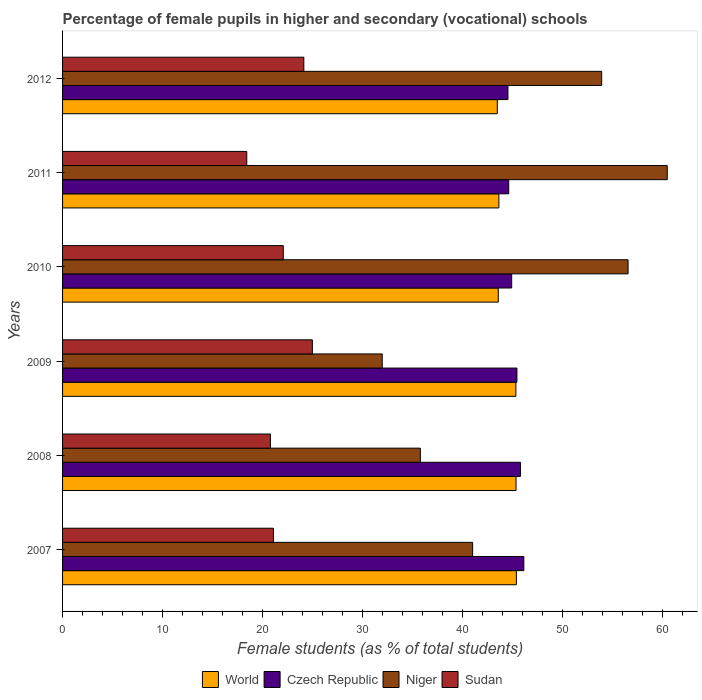How many different coloured bars are there?
Give a very brief answer. 4. How many groups of bars are there?
Provide a short and direct response. 6. How many bars are there on the 1st tick from the top?
Ensure brevity in your answer.  4. How many bars are there on the 6th tick from the bottom?
Ensure brevity in your answer.  4. What is the percentage of female pupils in higher and secondary schools in Niger in 2007?
Provide a short and direct response. 41.02. Across all years, what is the maximum percentage of female pupils in higher and secondary schools in Niger?
Your answer should be compact. 60.48. Across all years, what is the minimum percentage of female pupils in higher and secondary schools in Sudan?
Your answer should be compact. 18.42. What is the total percentage of female pupils in higher and secondary schools in Czech Republic in the graph?
Keep it short and to the point. 271.47. What is the difference between the percentage of female pupils in higher and secondary schools in Sudan in 2007 and that in 2008?
Make the answer very short. 0.3. What is the difference between the percentage of female pupils in higher and secondary schools in World in 2007 and the percentage of female pupils in higher and secondary schools in Sudan in 2012?
Provide a succinct answer. 21.26. What is the average percentage of female pupils in higher and secondary schools in Czech Republic per year?
Your answer should be compact. 45.25. In the year 2012, what is the difference between the percentage of female pupils in higher and secondary schools in World and percentage of female pupils in higher and secondary schools in Niger?
Offer a terse response. -10.44. In how many years, is the percentage of female pupils in higher and secondary schools in World greater than 38 %?
Keep it short and to the point. 6. What is the ratio of the percentage of female pupils in higher and secondary schools in Czech Republic in 2007 to that in 2010?
Your answer should be compact. 1.03. Is the difference between the percentage of female pupils in higher and secondary schools in World in 2007 and 2011 greater than the difference between the percentage of female pupils in higher and secondary schools in Niger in 2007 and 2011?
Keep it short and to the point. Yes. What is the difference between the highest and the second highest percentage of female pupils in higher and secondary schools in Sudan?
Provide a succinct answer. 0.85. What is the difference between the highest and the lowest percentage of female pupils in higher and secondary schools in World?
Keep it short and to the point. 1.91. In how many years, is the percentage of female pupils in higher and secondary schools in Niger greater than the average percentage of female pupils in higher and secondary schools in Niger taken over all years?
Ensure brevity in your answer.  3. Is it the case that in every year, the sum of the percentage of female pupils in higher and secondary schools in World and percentage of female pupils in higher and secondary schools in Sudan is greater than the sum of percentage of female pupils in higher and secondary schools in Niger and percentage of female pupils in higher and secondary schools in Czech Republic?
Make the answer very short. No. What does the 1st bar from the top in 2011 represents?
Offer a terse response. Sudan. What does the 3rd bar from the bottom in 2008 represents?
Your response must be concise. Niger. Is it the case that in every year, the sum of the percentage of female pupils in higher and secondary schools in Niger and percentage of female pupils in higher and secondary schools in World is greater than the percentage of female pupils in higher and secondary schools in Czech Republic?
Ensure brevity in your answer.  Yes. How many bars are there?
Provide a succinct answer. 24. Does the graph contain any zero values?
Offer a very short reply. No. Does the graph contain grids?
Provide a short and direct response. No. What is the title of the graph?
Offer a very short reply. Percentage of female pupils in higher and secondary (vocational) schools. Does "Rwanda" appear as one of the legend labels in the graph?
Your response must be concise. No. What is the label or title of the X-axis?
Your answer should be very brief. Female students (as % of total students). What is the label or title of the Y-axis?
Your response must be concise. Years. What is the Female students (as % of total students) in World in 2007?
Make the answer very short. 45.39. What is the Female students (as % of total students) in Czech Republic in 2007?
Provide a short and direct response. 46.14. What is the Female students (as % of total students) in Niger in 2007?
Ensure brevity in your answer.  41.02. What is the Female students (as % of total students) of Sudan in 2007?
Make the answer very short. 21.09. What is the Female students (as % of total students) of World in 2008?
Offer a very short reply. 45.36. What is the Female students (as % of total students) in Czech Republic in 2008?
Provide a succinct answer. 45.8. What is the Female students (as % of total students) of Niger in 2008?
Your answer should be compact. 35.79. What is the Female students (as % of total students) of Sudan in 2008?
Your response must be concise. 20.79. What is the Female students (as % of total students) of World in 2009?
Provide a short and direct response. 45.34. What is the Female students (as % of total students) of Czech Republic in 2009?
Ensure brevity in your answer.  45.45. What is the Female students (as % of total students) in Niger in 2009?
Your answer should be very brief. 31.97. What is the Female students (as % of total students) of Sudan in 2009?
Keep it short and to the point. 24.98. What is the Female students (as % of total students) in World in 2010?
Provide a succinct answer. 43.58. What is the Female students (as % of total students) in Czech Republic in 2010?
Make the answer very short. 44.92. What is the Female students (as % of total students) of Niger in 2010?
Your answer should be compact. 56.56. What is the Female students (as % of total students) of Sudan in 2010?
Provide a succinct answer. 22.08. What is the Female students (as % of total students) in World in 2011?
Offer a very short reply. 43.64. What is the Female students (as % of total students) in Czech Republic in 2011?
Offer a very short reply. 44.62. What is the Female students (as % of total students) in Niger in 2011?
Offer a very short reply. 60.48. What is the Female students (as % of total students) of Sudan in 2011?
Make the answer very short. 18.42. What is the Female students (as % of total students) of World in 2012?
Your answer should be compact. 43.48. What is the Female students (as % of total students) in Czech Republic in 2012?
Provide a short and direct response. 44.55. What is the Female students (as % of total students) of Niger in 2012?
Your answer should be compact. 53.92. What is the Female students (as % of total students) of Sudan in 2012?
Provide a succinct answer. 24.13. Across all years, what is the maximum Female students (as % of total students) in World?
Provide a short and direct response. 45.39. Across all years, what is the maximum Female students (as % of total students) in Czech Republic?
Give a very brief answer. 46.14. Across all years, what is the maximum Female students (as % of total students) of Niger?
Ensure brevity in your answer.  60.48. Across all years, what is the maximum Female students (as % of total students) of Sudan?
Offer a very short reply. 24.98. Across all years, what is the minimum Female students (as % of total students) in World?
Offer a terse response. 43.48. Across all years, what is the minimum Female students (as % of total students) in Czech Republic?
Your response must be concise. 44.55. Across all years, what is the minimum Female students (as % of total students) in Niger?
Ensure brevity in your answer.  31.97. Across all years, what is the minimum Female students (as % of total students) of Sudan?
Provide a succinct answer. 18.42. What is the total Female students (as % of total students) in World in the graph?
Keep it short and to the point. 266.79. What is the total Female students (as % of total students) in Czech Republic in the graph?
Offer a terse response. 271.47. What is the total Female students (as % of total students) of Niger in the graph?
Your response must be concise. 279.74. What is the total Female students (as % of total students) in Sudan in the graph?
Make the answer very short. 131.49. What is the difference between the Female students (as % of total students) of World in 2007 and that in 2008?
Provide a short and direct response. 0.03. What is the difference between the Female students (as % of total students) of Czech Republic in 2007 and that in 2008?
Keep it short and to the point. 0.34. What is the difference between the Female students (as % of total students) of Niger in 2007 and that in 2008?
Provide a succinct answer. 5.23. What is the difference between the Female students (as % of total students) of Sudan in 2007 and that in 2008?
Your answer should be compact. 0.3. What is the difference between the Female students (as % of total students) in World in 2007 and that in 2009?
Ensure brevity in your answer.  0.05. What is the difference between the Female students (as % of total students) in Czech Republic in 2007 and that in 2009?
Keep it short and to the point. 0.69. What is the difference between the Female students (as % of total students) of Niger in 2007 and that in 2009?
Offer a terse response. 9.04. What is the difference between the Female students (as % of total students) of Sudan in 2007 and that in 2009?
Provide a short and direct response. -3.89. What is the difference between the Female students (as % of total students) of World in 2007 and that in 2010?
Your answer should be very brief. 1.81. What is the difference between the Female students (as % of total students) in Czech Republic in 2007 and that in 2010?
Provide a short and direct response. 1.22. What is the difference between the Female students (as % of total students) of Niger in 2007 and that in 2010?
Give a very brief answer. -15.55. What is the difference between the Female students (as % of total students) in Sudan in 2007 and that in 2010?
Keep it short and to the point. -0.98. What is the difference between the Female students (as % of total students) of World in 2007 and that in 2011?
Offer a very short reply. 1.75. What is the difference between the Female students (as % of total students) in Czech Republic in 2007 and that in 2011?
Keep it short and to the point. 1.51. What is the difference between the Female students (as % of total students) in Niger in 2007 and that in 2011?
Offer a terse response. -19.47. What is the difference between the Female students (as % of total students) of Sudan in 2007 and that in 2011?
Ensure brevity in your answer.  2.67. What is the difference between the Female students (as % of total students) of World in 2007 and that in 2012?
Your answer should be very brief. 1.91. What is the difference between the Female students (as % of total students) of Czech Republic in 2007 and that in 2012?
Your answer should be very brief. 1.59. What is the difference between the Female students (as % of total students) of Niger in 2007 and that in 2012?
Provide a succinct answer. -12.91. What is the difference between the Female students (as % of total students) of Sudan in 2007 and that in 2012?
Provide a succinct answer. -3.04. What is the difference between the Female students (as % of total students) in World in 2008 and that in 2009?
Provide a succinct answer. 0.02. What is the difference between the Female students (as % of total students) in Czech Republic in 2008 and that in 2009?
Ensure brevity in your answer.  0.35. What is the difference between the Female students (as % of total students) of Niger in 2008 and that in 2009?
Give a very brief answer. 3.82. What is the difference between the Female students (as % of total students) in Sudan in 2008 and that in 2009?
Make the answer very short. -4.2. What is the difference between the Female students (as % of total students) of World in 2008 and that in 2010?
Keep it short and to the point. 1.78. What is the difference between the Female students (as % of total students) of Czech Republic in 2008 and that in 2010?
Your response must be concise. 0.88. What is the difference between the Female students (as % of total students) in Niger in 2008 and that in 2010?
Provide a short and direct response. -20.78. What is the difference between the Female students (as % of total students) in Sudan in 2008 and that in 2010?
Provide a short and direct response. -1.29. What is the difference between the Female students (as % of total students) of World in 2008 and that in 2011?
Provide a succinct answer. 1.72. What is the difference between the Female students (as % of total students) of Czech Republic in 2008 and that in 2011?
Give a very brief answer. 1.17. What is the difference between the Female students (as % of total students) of Niger in 2008 and that in 2011?
Your answer should be very brief. -24.69. What is the difference between the Female students (as % of total students) in Sudan in 2008 and that in 2011?
Make the answer very short. 2.37. What is the difference between the Female students (as % of total students) in World in 2008 and that in 2012?
Offer a terse response. 1.87. What is the difference between the Female students (as % of total students) of Czech Republic in 2008 and that in 2012?
Offer a very short reply. 1.25. What is the difference between the Female students (as % of total students) of Niger in 2008 and that in 2012?
Your response must be concise. -18.14. What is the difference between the Female students (as % of total students) of Sudan in 2008 and that in 2012?
Keep it short and to the point. -3.34. What is the difference between the Female students (as % of total students) of World in 2009 and that in 2010?
Your response must be concise. 1.76. What is the difference between the Female students (as % of total students) in Czech Republic in 2009 and that in 2010?
Make the answer very short. 0.52. What is the difference between the Female students (as % of total students) in Niger in 2009 and that in 2010?
Offer a very short reply. -24.59. What is the difference between the Female students (as % of total students) in Sudan in 2009 and that in 2010?
Your answer should be very brief. 2.91. What is the difference between the Female students (as % of total students) in World in 2009 and that in 2011?
Your answer should be compact. 1.7. What is the difference between the Female students (as % of total students) of Czech Republic in 2009 and that in 2011?
Make the answer very short. 0.82. What is the difference between the Female students (as % of total students) of Niger in 2009 and that in 2011?
Offer a terse response. -28.51. What is the difference between the Female students (as % of total students) in Sudan in 2009 and that in 2011?
Your response must be concise. 6.56. What is the difference between the Female students (as % of total students) of World in 2009 and that in 2012?
Keep it short and to the point. 1.86. What is the difference between the Female students (as % of total students) in Czech Republic in 2009 and that in 2012?
Your answer should be very brief. 0.9. What is the difference between the Female students (as % of total students) of Niger in 2009 and that in 2012?
Offer a terse response. -21.95. What is the difference between the Female students (as % of total students) in Sudan in 2009 and that in 2012?
Your response must be concise. 0.85. What is the difference between the Female students (as % of total students) of World in 2010 and that in 2011?
Ensure brevity in your answer.  -0.06. What is the difference between the Female students (as % of total students) in Czech Republic in 2010 and that in 2011?
Keep it short and to the point. 0.3. What is the difference between the Female students (as % of total students) of Niger in 2010 and that in 2011?
Provide a short and direct response. -3.92. What is the difference between the Female students (as % of total students) in Sudan in 2010 and that in 2011?
Provide a succinct answer. 3.65. What is the difference between the Female students (as % of total students) of World in 2010 and that in 2012?
Provide a succinct answer. 0.09. What is the difference between the Female students (as % of total students) in Czech Republic in 2010 and that in 2012?
Offer a terse response. 0.37. What is the difference between the Female students (as % of total students) in Niger in 2010 and that in 2012?
Provide a short and direct response. 2.64. What is the difference between the Female students (as % of total students) of Sudan in 2010 and that in 2012?
Your response must be concise. -2.06. What is the difference between the Female students (as % of total students) in World in 2011 and that in 2012?
Your answer should be compact. 0.16. What is the difference between the Female students (as % of total students) of Czech Republic in 2011 and that in 2012?
Ensure brevity in your answer.  0.08. What is the difference between the Female students (as % of total students) of Niger in 2011 and that in 2012?
Ensure brevity in your answer.  6.56. What is the difference between the Female students (as % of total students) of Sudan in 2011 and that in 2012?
Ensure brevity in your answer.  -5.71. What is the difference between the Female students (as % of total students) of World in 2007 and the Female students (as % of total students) of Czech Republic in 2008?
Ensure brevity in your answer.  -0.41. What is the difference between the Female students (as % of total students) of World in 2007 and the Female students (as % of total students) of Niger in 2008?
Offer a very short reply. 9.6. What is the difference between the Female students (as % of total students) of World in 2007 and the Female students (as % of total students) of Sudan in 2008?
Ensure brevity in your answer.  24.6. What is the difference between the Female students (as % of total students) of Czech Republic in 2007 and the Female students (as % of total students) of Niger in 2008?
Your answer should be very brief. 10.35. What is the difference between the Female students (as % of total students) of Czech Republic in 2007 and the Female students (as % of total students) of Sudan in 2008?
Offer a very short reply. 25.35. What is the difference between the Female students (as % of total students) of Niger in 2007 and the Female students (as % of total students) of Sudan in 2008?
Ensure brevity in your answer.  20.23. What is the difference between the Female students (as % of total students) of World in 2007 and the Female students (as % of total students) of Czech Republic in 2009?
Make the answer very short. -0.06. What is the difference between the Female students (as % of total students) in World in 2007 and the Female students (as % of total students) in Niger in 2009?
Ensure brevity in your answer.  13.42. What is the difference between the Female students (as % of total students) in World in 2007 and the Female students (as % of total students) in Sudan in 2009?
Offer a terse response. 20.4. What is the difference between the Female students (as % of total students) in Czech Republic in 2007 and the Female students (as % of total students) in Niger in 2009?
Offer a terse response. 14.17. What is the difference between the Female students (as % of total students) of Czech Republic in 2007 and the Female students (as % of total students) of Sudan in 2009?
Make the answer very short. 21.15. What is the difference between the Female students (as % of total students) in Niger in 2007 and the Female students (as % of total students) in Sudan in 2009?
Provide a succinct answer. 16.03. What is the difference between the Female students (as % of total students) of World in 2007 and the Female students (as % of total students) of Czech Republic in 2010?
Your answer should be compact. 0.47. What is the difference between the Female students (as % of total students) of World in 2007 and the Female students (as % of total students) of Niger in 2010?
Keep it short and to the point. -11.17. What is the difference between the Female students (as % of total students) of World in 2007 and the Female students (as % of total students) of Sudan in 2010?
Ensure brevity in your answer.  23.31. What is the difference between the Female students (as % of total students) of Czech Republic in 2007 and the Female students (as % of total students) of Niger in 2010?
Keep it short and to the point. -10.42. What is the difference between the Female students (as % of total students) of Czech Republic in 2007 and the Female students (as % of total students) of Sudan in 2010?
Provide a short and direct response. 24.06. What is the difference between the Female students (as % of total students) of Niger in 2007 and the Female students (as % of total students) of Sudan in 2010?
Give a very brief answer. 18.94. What is the difference between the Female students (as % of total students) in World in 2007 and the Female students (as % of total students) in Czech Republic in 2011?
Ensure brevity in your answer.  0.76. What is the difference between the Female students (as % of total students) of World in 2007 and the Female students (as % of total students) of Niger in 2011?
Provide a short and direct response. -15.09. What is the difference between the Female students (as % of total students) of World in 2007 and the Female students (as % of total students) of Sudan in 2011?
Keep it short and to the point. 26.97. What is the difference between the Female students (as % of total students) of Czech Republic in 2007 and the Female students (as % of total students) of Niger in 2011?
Your response must be concise. -14.34. What is the difference between the Female students (as % of total students) of Czech Republic in 2007 and the Female students (as % of total students) of Sudan in 2011?
Keep it short and to the point. 27.71. What is the difference between the Female students (as % of total students) in Niger in 2007 and the Female students (as % of total students) in Sudan in 2011?
Your response must be concise. 22.59. What is the difference between the Female students (as % of total students) in World in 2007 and the Female students (as % of total students) in Czech Republic in 2012?
Offer a terse response. 0.84. What is the difference between the Female students (as % of total students) in World in 2007 and the Female students (as % of total students) in Niger in 2012?
Keep it short and to the point. -8.53. What is the difference between the Female students (as % of total students) of World in 2007 and the Female students (as % of total students) of Sudan in 2012?
Your answer should be compact. 21.26. What is the difference between the Female students (as % of total students) of Czech Republic in 2007 and the Female students (as % of total students) of Niger in 2012?
Ensure brevity in your answer.  -7.78. What is the difference between the Female students (as % of total students) of Czech Republic in 2007 and the Female students (as % of total students) of Sudan in 2012?
Your answer should be compact. 22.01. What is the difference between the Female students (as % of total students) in Niger in 2007 and the Female students (as % of total students) in Sudan in 2012?
Offer a very short reply. 16.88. What is the difference between the Female students (as % of total students) in World in 2008 and the Female students (as % of total students) in Czech Republic in 2009?
Your response must be concise. -0.09. What is the difference between the Female students (as % of total students) in World in 2008 and the Female students (as % of total students) in Niger in 2009?
Your response must be concise. 13.39. What is the difference between the Female students (as % of total students) of World in 2008 and the Female students (as % of total students) of Sudan in 2009?
Your answer should be compact. 20.37. What is the difference between the Female students (as % of total students) of Czech Republic in 2008 and the Female students (as % of total students) of Niger in 2009?
Make the answer very short. 13.83. What is the difference between the Female students (as % of total students) in Czech Republic in 2008 and the Female students (as % of total students) in Sudan in 2009?
Your answer should be very brief. 20.81. What is the difference between the Female students (as % of total students) of Niger in 2008 and the Female students (as % of total students) of Sudan in 2009?
Offer a terse response. 10.8. What is the difference between the Female students (as % of total students) in World in 2008 and the Female students (as % of total students) in Czech Republic in 2010?
Offer a terse response. 0.44. What is the difference between the Female students (as % of total students) in World in 2008 and the Female students (as % of total students) in Niger in 2010?
Provide a short and direct response. -11.21. What is the difference between the Female students (as % of total students) in World in 2008 and the Female students (as % of total students) in Sudan in 2010?
Give a very brief answer. 23.28. What is the difference between the Female students (as % of total students) in Czech Republic in 2008 and the Female students (as % of total students) in Niger in 2010?
Provide a short and direct response. -10.77. What is the difference between the Female students (as % of total students) of Czech Republic in 2008 and the Female students (as % of total students) of Sudan in 2010?
Offer a very short reply. 23.72. What is the difference between the Female students (as % of total students) in Niger in 2008 and the Female students (as % of total students) in Sudan in 2010?
Ensure brevity in your answer.  13.71. What is the difference between the Female students (as % of total students) in World in 2008 and the Female students (as % of total students) in Czech Republic in 2011?
Your response must be concise. 0.73. What is the difference between the Female students (as % of total students) in World in 2008 and the Female students (as % of total students) in Niger in 2011?
Keep it short and to the point. -15.12. What is the difference between the Female students (as % of total students) in World in 2008 and the Female students (as % of total students) in Sudan in 2011?
Your answer should be compact. 26.93. What is the difference between the Female students (as % of total students) of Czech Republic in 2008 and the Female students (as % of total students) of Niger in 2011?
Your answer should be very brief. -14.68. What is the difference between the Female students (as % of total students) in Czech Republic in 2008 and the Female students (as % of total students) in Sudan in 2011?
Give a very brief answer. 27.37. What is the difference between the Female students (as % of total students) in Niger in 2008 and the Female students (as % of total students) in Sudan in 2011?
Offer a very short reply. 17.36. What is the difference between the Female students (as % of total students) in World in 2008 and the Female students (as % of total students) in Czech Republic in 2012?
Your answer should be compact. 0.81. What is the difference between the Female students (as % of total students) of World in 2008 and the Female students (as % of total students) of Niger in 2012?
Provide a succinct answer. -8.56. What is the difference between the Female students (as % of total students) in World in 2008 and the Female students (as % of total students) in Sudan in 2012?
Ensure brevity in your answer.  21.23. What is the difference between the Female students (as % of total students) of Czech Republic in 2008 and the Female students (as % of total students) of Niger in 2012?
Give a very brief answer. -8.12. What is the difference between the Female students (as % of total students) in Czech Republic in 2008 and the Female students (as % of total students) in Sudan in 2012?
Your response must be concise. 21.67. What is the difference between the Female students (as % of total students) in Niger in 2008 and the Female students (as % of total students) in Sudan in 2012?
Offer a very short reply. 11.66. What is the difference between the Female students (as % of total students) of World in 2009 and the Female students (as % of total students) of Czech Republic in 2010?
Your answer should be very brief. 0.42. What is the difference between the Female students (as % of total students) of World in 2009 and the Female students (as % of total students) of Niger in 2010?
Make the answer very short. -11.22. What is the difference between the Female students (as % of total students) in World in 2009 and the Female students (as % of total students) in Sudan in 2010?
Your answer should be very brief. 23.27. What is the difference between the Female students (as % of total students) of Czech Republic in 2009 and the Female students (as % of total students) of Niger in 2010?
Provide a succinct answer. -11.12. What is the difference between the Female students (as % of total students) in Czech Republic in 2009 and the Female students (as % of total students) in Sudan in 2010?
Give a very brief answer. 23.37. What is the difference between the Female students (as % of total students) of Niger in 2009 and the Female students (as % of total students) of Sudan in 2010?
Your response must be concise. 9.9. What is the difference between the Female students (as % of total students) of World in 2009 and the Female students (as % of total students) of Czech Republic in 2011?
Ensure brevity in your answer.  0.72. What is the difference between the Female students (as % of total students) in World in 2009 and the Female students (as % of total students) in Niger in 2011?
Ensure brevity in your answer.  -15.14. What is the difference between the Female students (as % of total students) in World in 2009 and the Female students (as % of total students) in Sudan in 2011?
Provide a succinct answer. 26.92. What is the difference between the Female students (as % of total students) in Czech Republic in 2009 and the Female students (as % of total students) in Niger in 2011?
Provide a short and direct response. -15.04. What is the difference between the Female students (as % of total students) of Czech Republic in 2009 and the Female students (as % of total students) of Sudan in 2011?
Make the answer very short. 27.02. What is the difference between the Female students (as % of total students) of Niger in 2009 and the Female students (as % of total students) of Sudan in 2011?
Your answer should be compact. 13.55. What is the difference between the Female students (as % of total students) in World in 2009 and the Female students (as % of total students) in Czech Republic in 2012?
Keep it short and to the point. 0.79. What is the difference between the Female students (as % of total students) in World in 2009 and the Female students (as % of total students) in Niger in 2012?
Offer a very short reply. -8.58. What is the difference between the Female students (as % of total students) in World in 2009 and the Female students (as % of total students) in Sudan in 2012?
Your response must be concise. 21.21. What is the difference between the Female students (as % of total students) of Czech Republic in 2009 and the Female students (as % of total students) of Niger in 2012?
Offer a very short reply. -8.48. What is the difference between the Female students (as % of total students) in Czech Republic in 2009 and the Female students (as % of total students) in Sudan in 2012?
Make the answer very short. 21.31. What is the difference between the Female students (as % of total students) in Niger in 2009 and the Female students (as % of total students) in Sudan in 2012?
Your answer should be very brief. 7.84. What is the difference between the Female students (as % of total students) of World in 2010 and the Female students (as % of total students) of Czech Republic in 2011?
Offer a terse response. -1.05. What is the difference between the Female students (as % of total students) of World in 2010 and the Female students (as % of total students) of Niger in 2011?
Provide a succinct answer. -16.9. What is the difference between the Female students (as % of total students) of World in 2010 and the Female students (as % of total students) of Sudan in 2011?
Offer a terse response. 25.15. What is the difference between the Female students (as % of total students) of Czech Republic in 2010 and the Female students (as % of total students) of Niger in 2011?
Your answer should be very brief. -15.56. What is the difference between the Female students (as % of total students) in Czech Republic in 2010 and the Female students (as % of total students) in Sudan in 2011?
Provide a short and direct response. 26.5. What is the difference between the Female students (as % of total students) in Niger in 2010 and the Female students (as % of total students) in Sudan in 2011?
Provide a succinct answer. 38.14. What is the difference between the Female students (as % of total students) in World in 2010 and the Female students (as % of total students) in Czech Republic in 2012?
Make the answer very short. -0.97. What is the difference between the Female students (as % of total students) in World in 2010 and the Female students (as % of total students) in Niger in 2012?
Keep it short and to the point. -10.34. What is the difference between the Female students (as % of total students) of World in 2010 and the Female students (as % of total students) of Sudan in 2012?
Give a very brief answer. 19.45. What is the difference between the Female students (as % of total students) in Czech Republic in 2010 and the Female students (as % of total students) in Niger in 2012?
Give a very brief answer. -9. What is the difference between the Female students (as % of total students) of Czech Republic in 2010 and the Female students (as % of total students) of Sudan in 2012?
Keep it short and to the point. 20.79. What is the difference between the Female students (as % of total students) in Niger in 2010 and the Female students (as % of total students) in Sudan in 2012?
Provide a short and direct response. 32.43. What is the difference between the Female students (as % of total students) of World in 2011 and the Female students (as % of total students) of Czech Republic in 2012?
Provide a short and direct response. -0.91. What is the difference between the Female students (as % of total students) in World in 2011 and the Female students (as % of total students) in Niger in 2012?
Offer a terse response. -10.28. What is the difference between the Female students (as % of total students) of World in 2011 and the Female students (as % of total students) of Sudan in 2012?
Give a very brief answer. 19.51. What is the difference between the Female students (as % of total students) of Czech Republic in 2011 and the Female students (as % of total students) of Niger in 2012?
Offer a very short reply. -9.3. What is the difference between the Female students (as % of total students) in Czech Republic in 2011 and the Female students (as % of total students) in Sudan in 2012?
Provide a short and direct response. 20.49. What is the difference between the Female students (as % of total students) of Niger in 2011 and the Female students (as % of total students) of Sudan in 2012?
Make the answer very short. 36.35. What is the average Female students (as % of total students) of World per year?
Your answer should be very brief. 44.47. What is the average Female students (as % of total students) of Czech Republic per year?
Offer a terse response. 45.25. What is the average Female students (as % of total students) in Niger per year?
Your response must be concise. 46.62. What is the average Female students (as % of total students) of Sudan per year?
Keep it short and to the point. 21.92. In the year 2007, what is the difference between the Female students (as % of total students) of World and Female students (as % of total students) of Czech Republic?
Give a very brief answer. -0.75. In the year 2007, what is the difference between the Female students (as % of total students) of World and Female students (as % of total students) of Niger?
Make the answer very short. 4.37. In the year 2007, what is the difference between the Female students (as % of total students) in World and Female students (as % of total students) in Sudan?
Your answer should be compact. 24.3. In the year 2007, what is the difference between the Female students (as % of total students) in Czech Republic and Female students (as % of total students) in Niger?
Provide a succinct answer. 5.12. In the year 2007, what is the difference between the Female students (as % of total students) in Czech Republic and Female students (as % of total students) in Sudan?
Make the answer very short. 25.05. In the year 2007, what is the difference between the Female students (as % of total students) of Niger and Female students (as % of total students) of Sudan?
Keep it short and to the point. 19.92. In the year 2008, what is the difference between the Female students (as % of total students) of World and Female students (as % of total students) of Czech Republic?
Give a very brief answer. -0.44. In the year 2008, what is the difference between the Female students (as % of total students) in World and Female students (as % of total students) in Niger?
Offer a terse response. 9.57. In the year 2008, what is the difference between the Female students (as % of total students) in World and Female students (as % of total students) in Sudan?
Offer a terse response. 24.57. In the year 2008, what is the difference between the Female students (as % of total students) in Czech Republic and Female students (as % of total students) in Niger?
Give a very brief answer. 10.01. In the year 2008, what is the difference between the Female students (as % of total students) of Czech Republic and Female students (as % of total students) of Sudan?
Ensure brevity in your answer.  25.01. In the year 2008, what is the difference between the Female students (as % of total students) of Niger and Female students (as % of total students) of Sudan?
Offer a terse response. 15. In the year 2009, what is the difference between the Female students (as % of total students) of World and Female students (as % of total students) of Czech Republic?
Provide a succinct answer. -0.1. In the year 2009, what is the difference between the Female students (as % of total students) of World and Female students (as % of total students) of Niger?
Your response must be concise. 13.37. In the year 2009, what is the difference between the Female students (as % of total students) of World and Female students (as % of total students) of Sudan?
Keep it short and to the point. 20.36. In the year 2009, what is the difference between the Female students (as % of total students) of Czech Republic and Female students (as % of total students) of Niger?
Give a very brief answer. 13.47. In the year 2009, what is the difference between the Female students (as % of total students) of Czech Republic and Female students (as % of total students) of Sudan?
Provide a succinct answer. 20.46. In the year 2009, what is the difference between the Female students (as % of total students) of Niger and Female students (as % of total students) of Sudan?
Your answer should be very brief. 6.99. In the year 2010, what is the difference between the Female students (as % of total students) in World and Female students (as % of total students) in Czech Republic?
Your answer should be very brief. -1.34. In the year 2010, what is the difference between the Female students (as % of total students) of World and Female students (as % of total students) of Niger?
Ensure brevity in your answer.  -12.98. In the year 2010, what is the difference between the Female students (as % of total students) of World and Female students (as % of total students) of Sudan?
Provide a short and direct response. 21.5. In the year 2010, what is the difference between the Female students (as % of total students) in Czech Republic and Female students (as % of total students) in Niger?
Offer a terse response. -11.64. In the year 2010, what is the difference between the Female students (as % of total students) of Czech Republic and Female students (as % of total students) of Sudan?
Provide a succinct answer. 22.85. In the year 2010, what is the difference between the Female students (as % of total students) in Niger and Female students (as % of total students) in Sudan?
Ensure brevity in your answer.  34.49. In the year 2011, what is the difference between the Female students (as % of total students) of World and Female students (as % of total students) of Czech Republic?
Your answer should be compact. -0.98. In the year 2011, what is the difference between the Female students (as % of total students) of World and Female students (as % of total students) of Niger?
Make the answer very short. -16.84. In the year 2011, what is the difference between the Female students (as % of total students) of World and Female students (as % of total students) of Sudan?
Offer a very short reply. 25.22. In the year 2011, what is the difference between the Female students (as % of total students) in Czech Republic and Female students (as % of total students) in Niger?
Your answer should be compact. -15.86. In the year 2011, what is the difference between the Female students (as % of total students) of Czech Republic and Female students (as % of total students) of Sudan?
Your answer should be compact. 26.2. In the year 2011, what is the difference between the Female students (as % of total students) in Niger and Female students (as % of total students) in Sudan?
Your answer should be very brief. 42.06. In the year 2012, what is the difference between the Female students (as % of total students) of World and Female students (as % of total students) of Czech Republic?
Your response must be concise. -1.06. In the year 2012, what is the difference between the Female students (as % of total students) of World and Female students (as % of total students) of Niger?
Your response must be concise. -10.44. In the year 2012, what is the difference between the Female students (as % of total students) in World and Female students (as % of total students) in Sudan?
Offer a terse response. 19.35. In the year 2012, what is the difference between the Female students (as % of total students) in Czech Republic and Female students (as % of total students) in Niger?
Keep it short and to the point. -9.37. In the year 2012, what is the difference between the Female students (as % of total students) of Czech Republic and Female students (as % of total students) of Sudan?
Your answer should be compact. 20.42. In the year 2012, what is the difference between the Female students (as % of total students) of Niger and Female students (as % of total students) of Sudan?
Provide a succinct answer. 29.79. What is the ratio of the Female students (as % of total students) in World in 2007 to that in 2008?
Give a very brief answer. 1. What is the ratio of the Female students (as % of total students) in Czech Republic in 2007 to that in 2008?
Make the answer very short. 1.01. What is the ratio of the Female students (as % of total students) of Niger in 2007 to that in 2008?
Give a very brief answer. 1.15. What is the ratio of the Female students (as % of total students) of Sudan in 2007 to that in 2008?
Your answer should be very brief. 1.01. What is the ratio of the Female students (as % of total students) of Czech Republic in 2007 to that in 2009?
Ensure brevity in your answer.  1.02. What is the ratio of the Female students (as % of total students) of Niger in 2007 to that in 2009?
Your answer should be very brief. 1.28. What is the ratio of the Female students (as % of total students) in Sudan in 2007 to that in 2009?
Your answer should be very brief. 0.84. What is the ratio of the Female students (as % of total students) in World in 2007 to that in 2010?
Your answer should be very brief. 1.04. What is the ratio of the Female students (as % of total students) in Czech Republic in 2007 to that in 2010?
Offer a terse response. 1.03. What is the ratio of the Female students (as % of total students) in Niger in 2007 to that in 2010?
Provide a succinct answer. 0.73. What is the ratio of the Female students (as % of total students) in Sudan in 2007 to that in 2010?
Make the answer very short. 0.96. What is the ratio of the Female students (as % of total students) in World in 2007 to that in 2011?
Your answer should be very brief. 1.04. What is the ratio of the Female students (as % of total students) of Czech Republic in 2007 to that in 2011?
Offer a terse response. 1.03. What is the ratio of the Female students (as % of total students) in Niger in 2007 to that in 2011?
Your answer should be very brief. 0.68. What is the ratio of the Female students (as % of total students) in Sudan in 2007 to that in 2011?
Your answer should be very brief. 1.14. What is the ratio of the Female students (as % of total students) of World in 2007 to that in 2012?
Your answer should be very brief. 1.04. What is the ratio of the Female students (as % of total students) in Czech Republic in 2007 to that in 2012?
Provide a succinct answer. 1.04. What is the ratio of the Female students (as % of total students) in Niger in 2007 to that in 2012?
Your response must be concise. 0.76. What is the ratio of the Female students (as % of total students) in Sudan in 2007 to that in 2012?
Provide a short and direct response. 0.87. What is the ratio of the Female students (as % of total students) in Czech Republic in 2008 to that in 2009?
Offer a terse response. 1.01. What is the ratio of the Female students (as % of total students) of Niger in 2008 to that in 2009?
Offer a terse response. 1.12. What is the ratio of the Female students (as % of total students) of Sudan in 2008 to that in 2009?
Make the answer very short. 0.83. What is the ratio of the Female students (as % of total students) in World in 2008 to that in 2010?
Offer a terse response. 1.04. What is the ratio of the Female students (as % of total students) in Czech Republic in 2008 to that in 2010?
Your answer should be compact. 1.02. What is the ratio of the Female students (as % of total students) of Niger in 2008 to that in 2010?
Give a very brief answer. 0.63. What is the ratio of the Female students (as % of total students) of Sudan in 2008 to that in 2010?
Offer a terse response. 0.94. What is the ratio of the Female students (as % of total students) of World in 2008 to that in 2011?
Ensure brevity in your answer.  1.04. What is the ratio of the Female students (as % of total students) in Czech Republic in 2008 to that in 2011?
Offer a terse response. 1.03. What is the ratio of the Female students (as % of total students) of Niger in 2008 to that in 2011?
Offer a very short reply. 0.59. What is the ratio of the Female students (as % of total students) of Sudan in 2008 to that in 2011?
Your answer should be very brief. 1.13. What is the ratio of the Female students (as % of total students) of World in 2008 to that in 2012?
Your response must be concise. 1.04. What is the ratio of the Female students (as % of total students) in Czech Republic in 2008 to that in 2012?
Provide a short and direct response. 1.03. What is the ratio of the Female students (as % of total students) in Niger in 2008 to that in 2012?
Your response must be concise. 0.66. What is the ratio of the Female students (as % of total students) in Sudan in 2008 to that in 2012?
Make the answer very short. 0.86. What is the ratio of the Female students (as % of total students) of World in 2009 to that in 2010?
Keep it short and to the point. 1.04. What is the ratio of the Female students (as % of total students) of Czech Republic in 2009 to that in 2010?
Keep it short and to the point. 1.01. What is the ratio of the Female students (as % of total students) of Niger in 2009 to that in 2010?
Keep it short and to the point. 0.57. What is the ratio of the Female students (as % of total students) in Sudan in 2009 to that in 2010?
Your response must be concise. 1.13. What is the ratio of the Female students (as % of total students) of World in 2009 to that in 2011?
Your answer should be very brief. 1.04. What is the ratio of the Female students (as % of total students) in Czech Republic in 2009 to that in 2011?
Your answer should be very brief. 1.02. What is the ratio of the Female students (as % of total students) in Niger in 2009 to that in 2011?
Ensure brevity in your answer.  0.53. What is the ratio of the Female students (as % of total students) in Sudan in 2009 to that in 2011?
Your answer should be compact. 1.36. What is the ratio of the Female students (as % of total students) in World in 2009 to that in 2012?
Provide a succinct answer. 1.04. What is the ratio of the Female students (as % of total students) in Czech Republic in 2009 to that in 2012?
Make the answer very short. 1.02. What is the ratio of the Female students (as % of total students) in Niger in 2009 to that in 2012?
Offer a terse response. 0.59. What is the ratio of the Female students (as % of total students) of Sudan in 2009 to that in 2012?
Your answer should be compact. 1.04. What is the ratio of the Female students (as % of total students) in Czech Republic in 2010 to that in 2011?
Keep it short and to the point. 1.01. What is the ratio of the Female students (as % of total students) in Niger in 2010 to that in 2011?
Provide a short and direct response. 0.94. What is the ratio of the Female students (as % of total students) in Sudan in 2010 to that in 2011?
Provide a short and direct response. 1.2. What is the ratio of the Female students (as % of total students) in World in 2010 to that in 2012?
Provide a short and direct response. 1. What is the ratio of the Female students (as % of total students) of Czech Republic in 2010 to that in 2012?
Your answer should be compact. 1.01. What is the ratio of the Female students (as % of total students) of Niger in 2010 to that in 2012?
Your response must be concise. 1.05. What is the ratio of the Female students (as % of total students) in Sudan in 2010 to that in 2012?
Give a very brief answer. 0.91. What is the ratio of the Female students (as % of total students) of Niger in 2011 to that in 2012?
Your answer should be very brief. 1.12. What is the ratio of the Female students (as % of total students) of Sudan in 2011 to that in 2012?
Keep it short and to the point. 0.76. What is the difference between the highest and the second highest Female students (as % of total students) of World?
Ensure brevity in your answer.  0.03. What is the difference between the highest and the second highest Female students (as % of total students) in Czech Republic?
Your answer should be very brief. 0.34. What is the difference between the highest and the second highest Female students (as % of total students) in Niger?
Offer a very short reply. 3.92. What is the difference between the highest and the second highest Female students (as % of total students) of Sudan?
Your answer should be compact. 0.85. What is the difference between the highest and the lowest Female students (as % of total students) of World?
Offer a terse response. 1.91. What is the difference between the highest and the lowest Female students (as % of total students) of Czech Republic?
Your answer should be compact. 1.59. What is the difference between the highest and the lowest Female students (as % of total students) in Niger?
Ensure brevity in your answer.  28.51. What is the difference between the highest and the lowest Female students (as % of total students) in Sudan?
Ensure brevity in your answer.  6.56. 